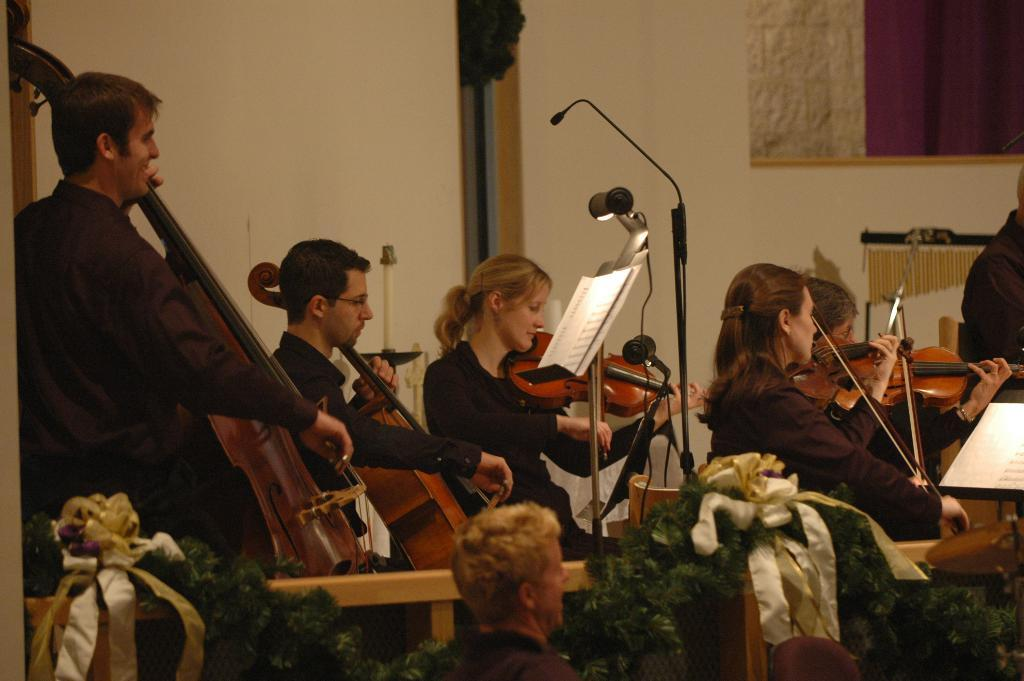What can be seen in the background of the image? There is a wall in the image. What are the people in the image doing? The people are sitting and holding guitars. What object is present for amplifying sound? There is a microphone in the image. What type of material can be seen in the image? There is a paper in the image. Can you tell me how many wings are visible in the image? There are no wings present in the image. What type of treatment is being administered to the people in the image? There is no treatment being administered in the image; the people are sitting and holding guitars. 